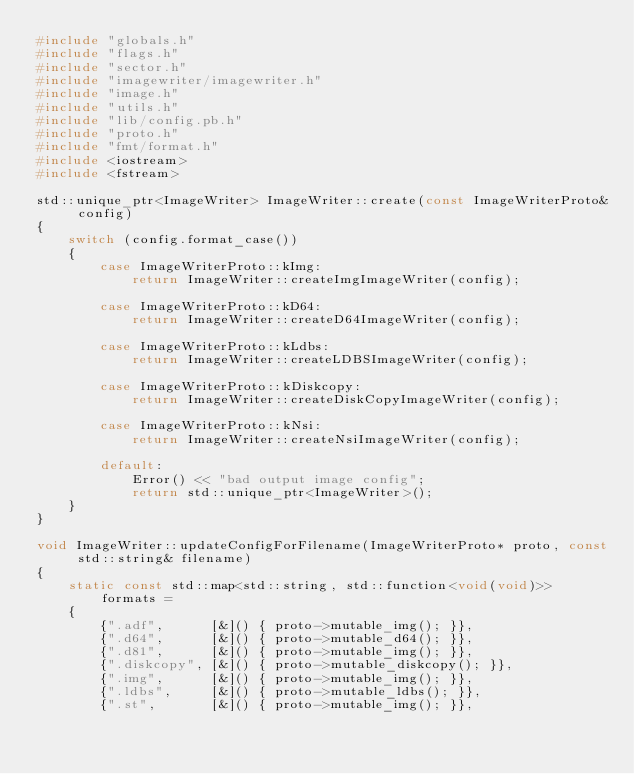Convert code to text. <code><loc_0><loc_0><loc_500><loc_500><_C++_>#include "globals.h"
#include "flags.h"
#include "sector.h"
#include "imagewriter/imagewriter.h"
#include "image.h"
#include "utils.h"
#include "lib/config.pb.h"
#include "proto.h"
#include "fmt/format.h"
#include <iostream>
#include <fstream>

std::unique_ptr<ImageWriter> ImageWriter::create(const ImageWriterProto& config)
{
	switch (config.format_case())
	{
		case ImageWriterProto::kImg:
			return ImageWriter::createImgImageWriter(config);

		case ImageWriterProto::kD64:
			return ImageWriter::createD64ImageWriter(config);

		case ImageWriterProto::kLdbs:
			return ImageWriter::createLDBSImageWriter(config);

		case ImageWriterProto::kDiskcopy:
			return ImageWriter::createDiskCopyImageWriter(config);

		case ImageWriterProto::kNsi:
			return ImageWriter::createNsiImageWriter(config);

		default:
			Error() << "bad output image config";
			return std::unique_ptr<ImageWriter>();
	}
}

void ImageWriter::updateConfigForFilename(ImageWriterProto* proto, const std::string& filename)
{
	static const std::map<std::string, std::function<void(void)>> formats =
	{
		{".adf",      [&]() { proto->mutable_img(); }},
		{".d64",      [&]() { proto->mutable_d64(); }},
		{".d81",      [&]() { proto->mutable_img(); }},
		{".diskcopy", [&]() { proto->mutable_diskcopy(); }},
		{".img",      [&]() { proto->mutable_img(); }},
		{".ldbs",     [&]() { proto->mutable_ldbs(); }},
		{".st",       [&]() { proto->mutable_img(); }},</code> 